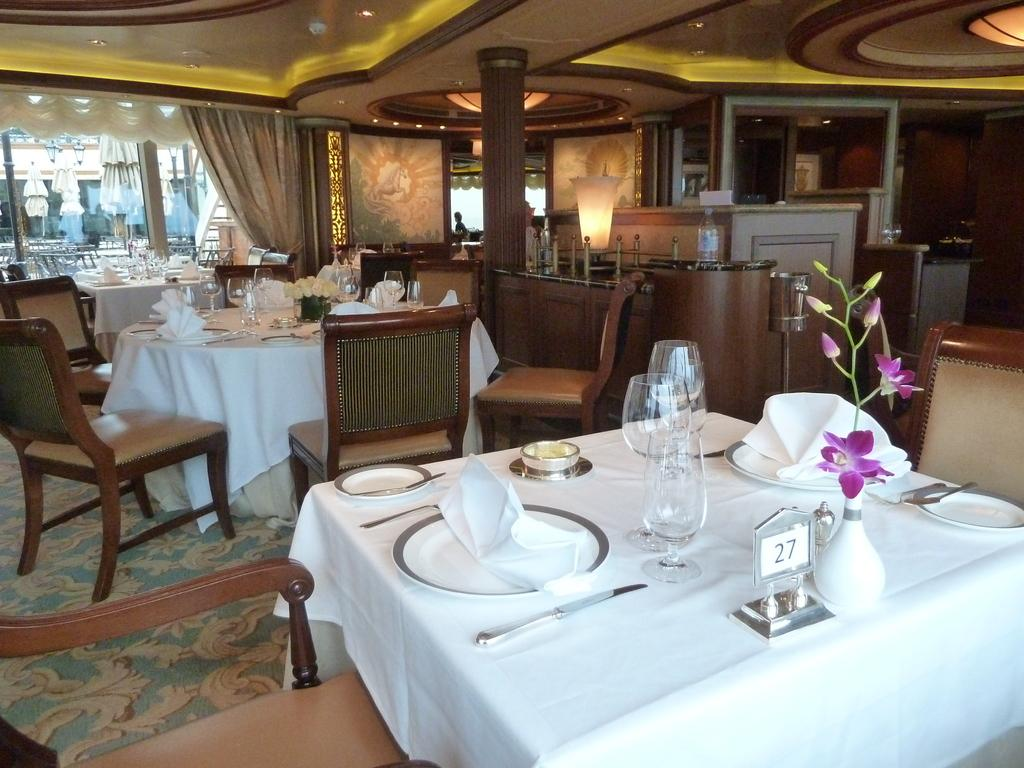What type of furniture can be seen in the image? There are tables and chairs in the image. What items are placed on the table? There are plates, knives, forks, spoons, tissue papers, and glasses on the table. What is covering the table? There is a cloth on the table. What can be seen in the background of the image? There are curtains, a pillar, and a lamp in the background. What type of string instrument is being played in the image? There is no string instrument or any musical instrument present in the image. What type of wool clothing is visible on the people in the image? There are no people or clothing visible in the image. 